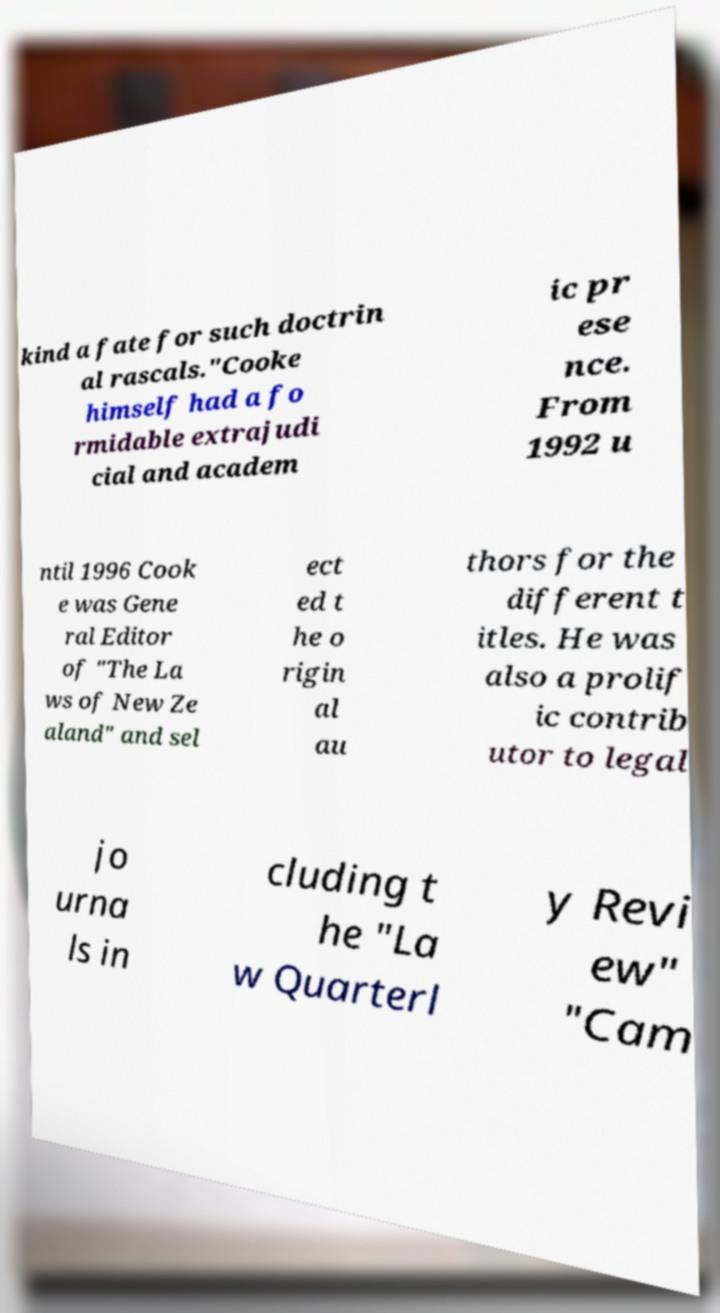Could you assist in decoding the text presented in this image and type it out clearly? kind a fate for such doctrin al rascals."Cooke himself had a fo rmidable extrajudi cial and academ ic pr ese nce. From 1992 u ntil 1996 Cook e was Gene ral Editor of "The La ws of New Ze aland" and sel ect ed t he o rigin al au thors for the different t itles. He was also a prolif ic contrib utor to legal jo urna ls in cluding t he "La w Quarterl y Revi ew" "Cam 